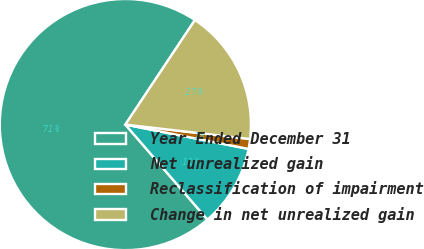Convert chart to OTSL. <chart><loc_0><loc_0><loc_500><loc_500><pie_chart><fcel>Year Ended December 31<fcel>Net unrealized gain<fcel>Reclassification of impairment<fcel>Change in net unrealized gain<nl><fcel>70.69%<fcel>10.55%<fcel>1.27%<fcel>17.49%<nl></chart> 